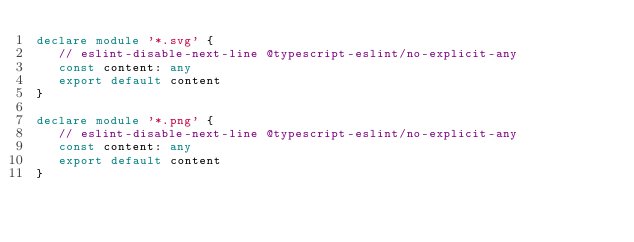Convert code to text. <code><loc_0><loc_0><loc_500><loc_500><_TypeScript_>declare module '*.svg' {
   // eslint-disable-next-line @typescript-eslint/no-explicit-any
   const content: any
   export default content
}

declare module '*.png' {
   // eslint-disable-next-line @typescript-eslint/no-explicit-any
   const content: any
   export default content
}
</code> 